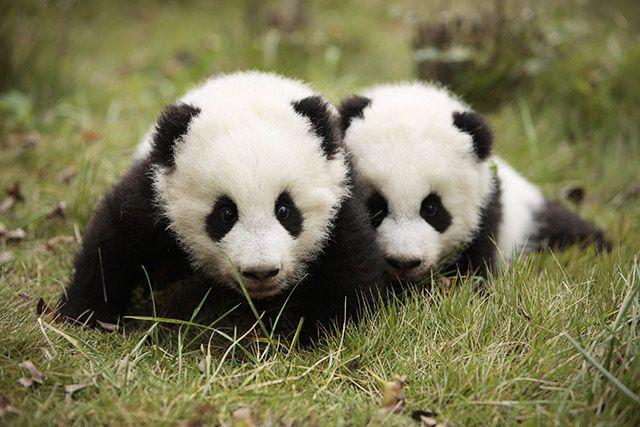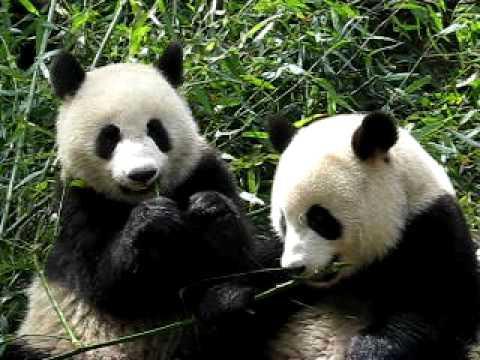The first image is the image on the left, the second image is the image on the right. For the images shown, is this caption "There are four pandas." true? Answer yes or no. Yes. The first image is the image on the left, the second image is the image on the right. Given the left and right images, does the statement "There are four pandas." hold true? Answer yes or no. Yes. 